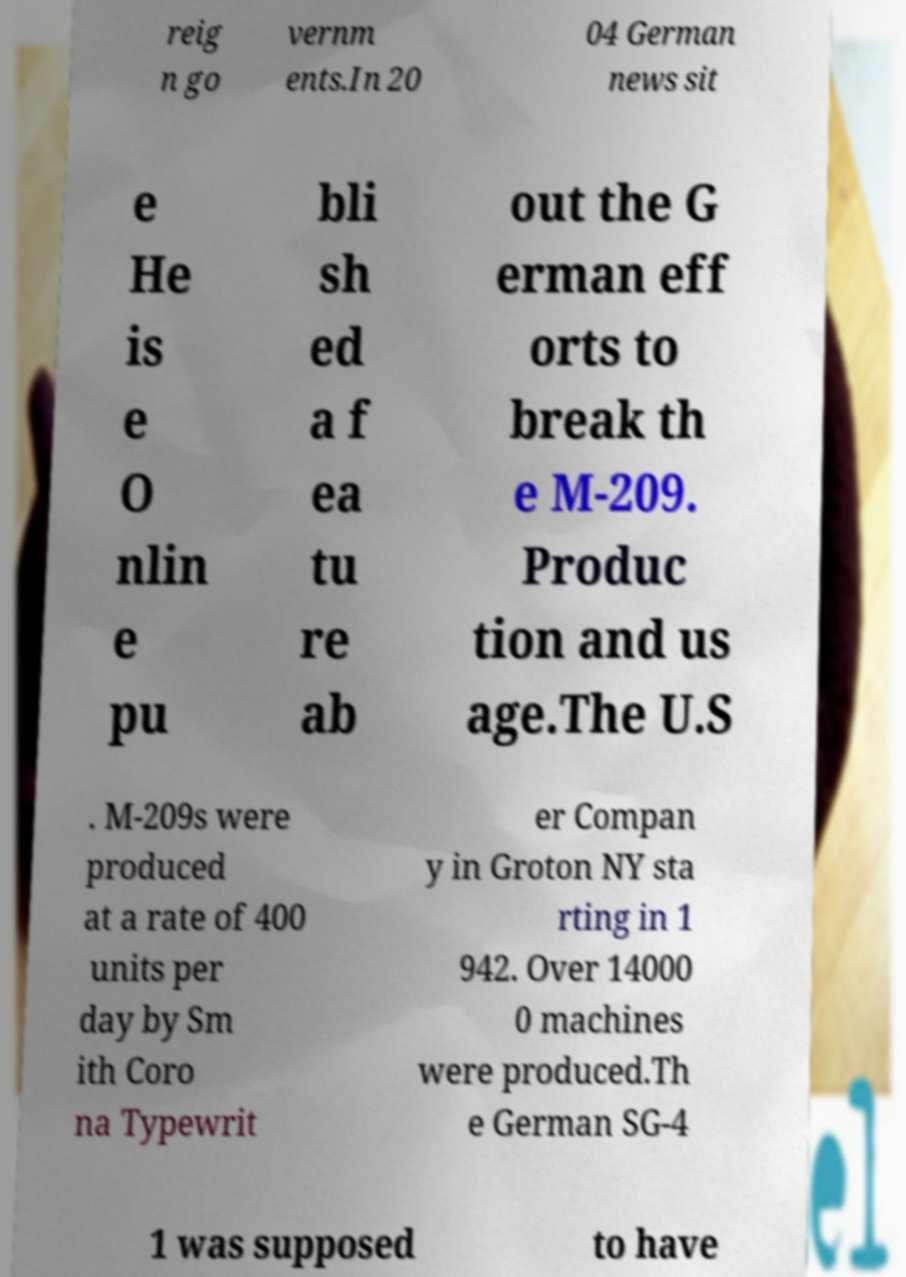Could you assist in decoding the text presented in this image and type it out clearly? reig n go vernm ents.In 20 04 German news sit e He is e O nlin e pu bli sh ed a f ea tu re ab out the G erman eff orts to break th e M-209. Produc tion and us age.The U.S . M-209s were produced at a rate of 400 units per day by Sm ith Coro na Typewrit er Compan y in Groton NY sta rting in 1 942. Over 14000 0 machines were produced.Th e German SG-4 1 was supposed to have 